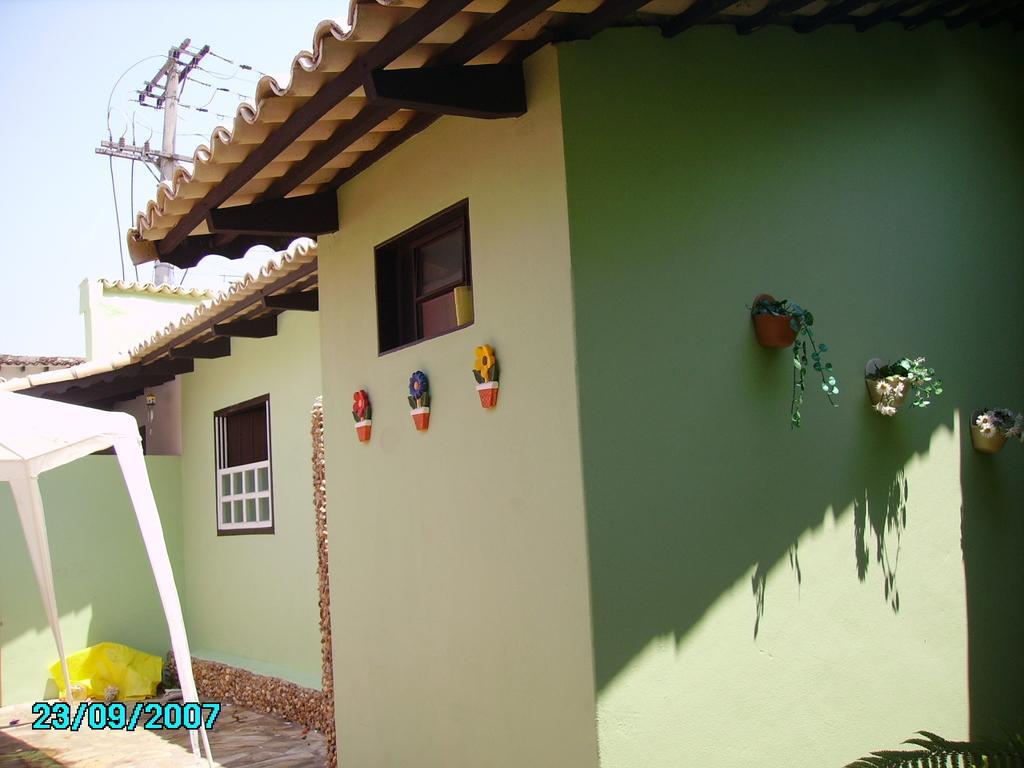Could you give a brief overview of what you see in this image? In this picture there is a building and there are plants and there are artificial flowers on the wall. On the left side of the image there it looks like a tent and there is a sheet and there is a window and there are wires on the pole. At the top there is sky and there are roof tiles on the top of the building. At the bottom there is a floor. 